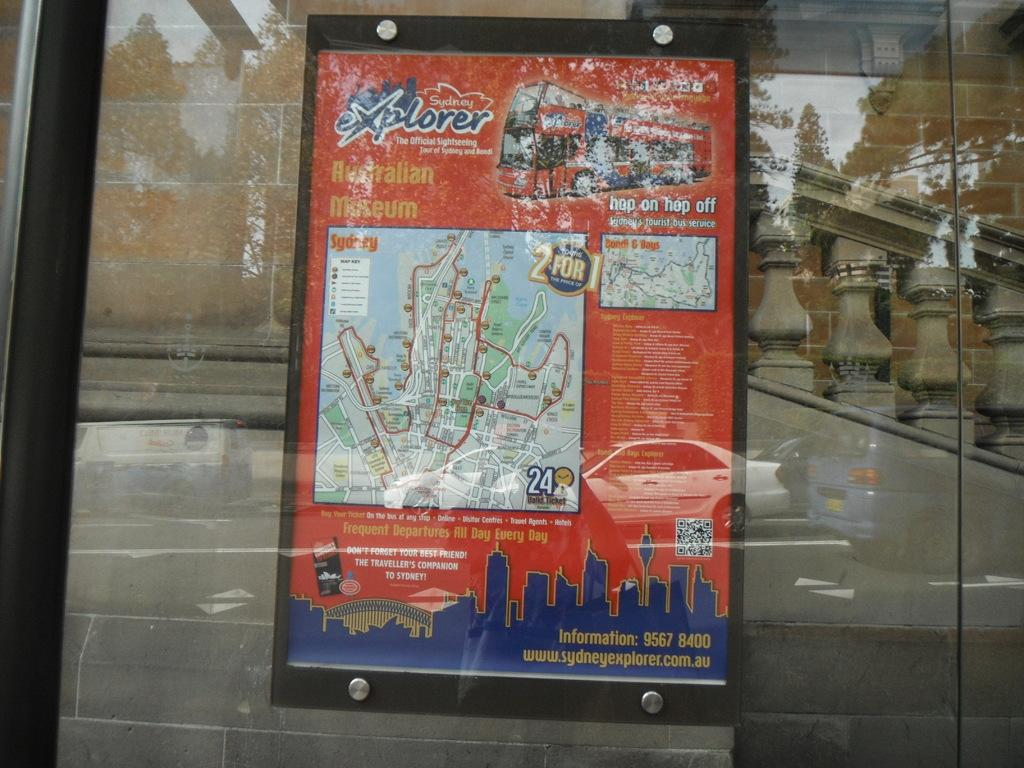<image>
Describe the image concisely. A poster in a window advertising a site seeing tour from the Sydney Explorer. 